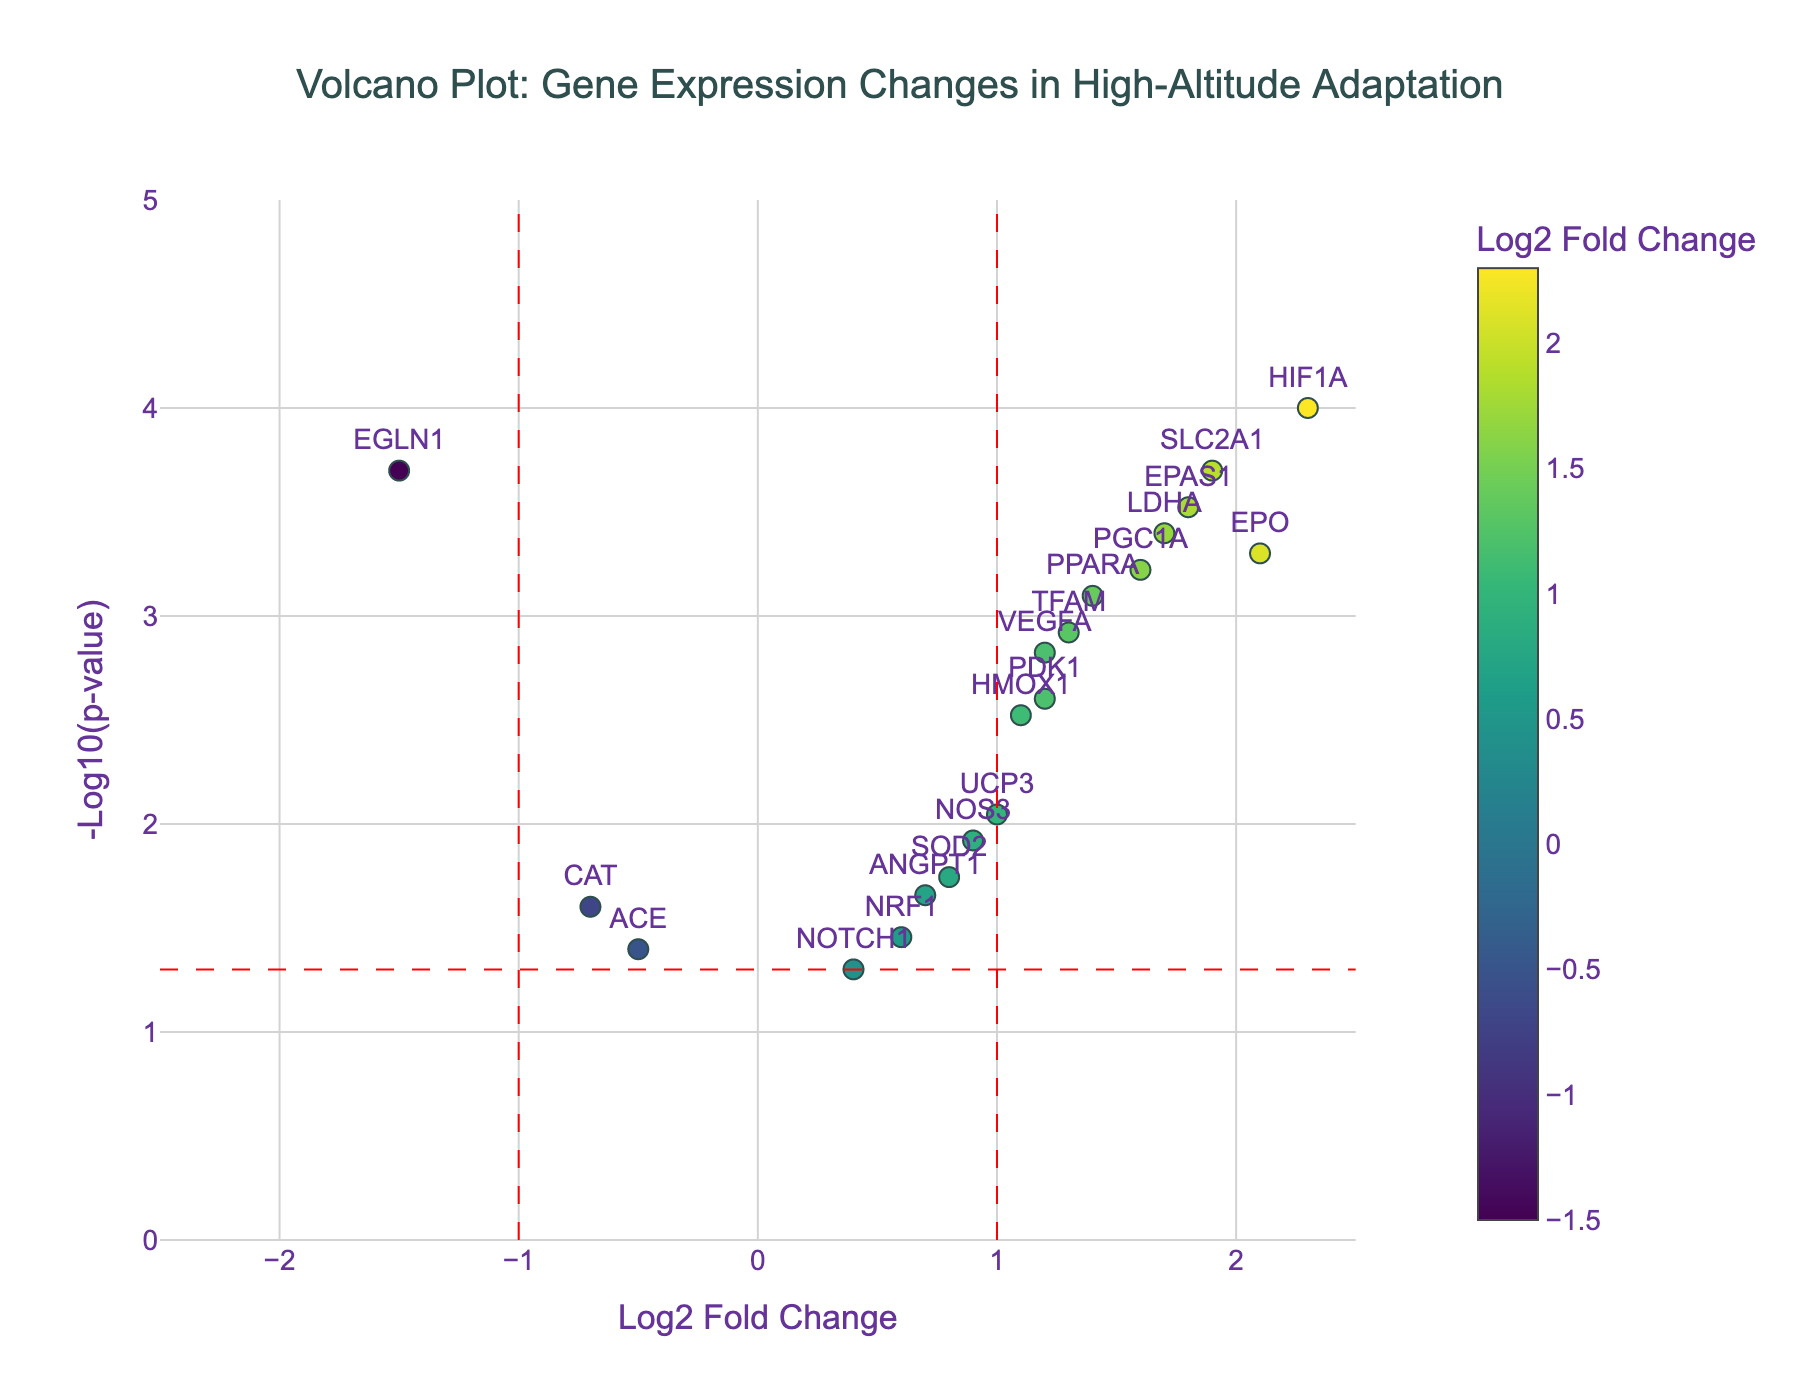what is the title of the plot? The title is usually located at the top of the figure. By observing, we can see that it is positioned at the center.
Answer: Volcano Plot: Gene Expression Changes in High-Altitude Adaptation How many genes have a Log2 Fold Change greater than 2? Count the number of data points (genes) on the plot where the x-axis value (Log2 Fold Change) exceeds 2. Only one data point (gene HIF1A) exists beyond this value.
Answer: 1 What is the significance threshold for the p-value in this plot, represented by a horizontal line? The red dashed horizontal line on the plot signifies the p-value threshold, which is labeled at around y = -log10(0.05).
Answer: 0.05 Which gene has the highest -log10(p-value)? To determine this, look for the highest point on the y-axis. The gene SLC2A1 has the highest -log10(p-value) of around 3.7.
Answer: SLC2A1 How many genes have both a log2FoldChange greater than 1 and a p-value less than 0.001? Look for data points (genes) where the x-axis value exceeds 1 and the y-axis value is above -log10(0.001), around 3. The genes that meet both criteria are HIF1A, EPAS1, SLC2A1.
Answer: 3 Which gene has the smallest log2FoldChange? Find the data point with the lowest x-value on the plot. The gene EGLN1 shows the smallest log2FoldChange at -1.5.
Answer: EGLN1 How many genes are not statistically significant based on the p-value threshold? Genes are statistically significant if their y-value is above the red dashed horizontal line. The genes NRF1, ACE, NOTCH1 have -log10(p-value) below 1.3, indicating they are not statistically significant.
Answer: 3 Which gene has the largest log2FoldChange among those with a p-value < 0.001? Identify all genes where y-value is greater than about 3, and note the one with the highest x-value. HIF1A has the largest log2FoldChange of 2.3 among the genes with significant p-values.
Answer: HIF1A What's the range of -log10(p-value) values displayed in the plot? Observe the lowest and highest points along the y-axis. The plot ranges from just below 1 to just below 4.
Answer: approximately 0 to 4 